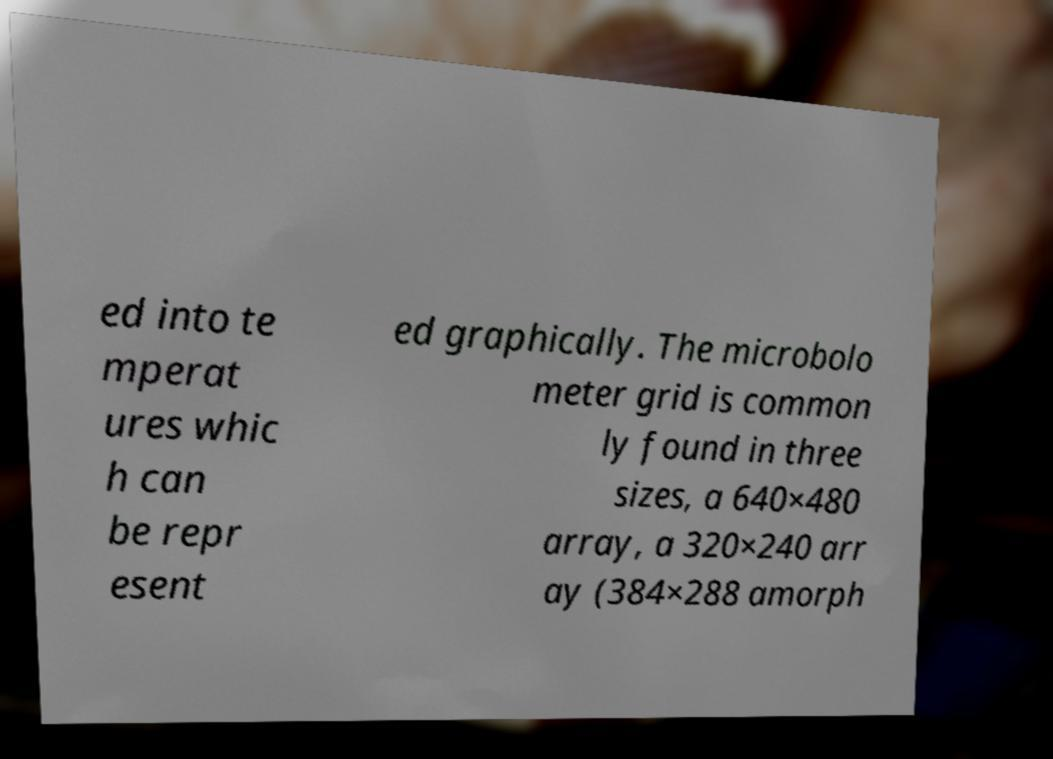For documentation purposes, I need the text within this image transcribed. Could you provide that? ed into te mperat ures whic h can be repr esent ed graphically. The microbolo meter grid is common ly found in three sizes, a 640×480 array, a 320×240 arr ay (384×288 amorph 